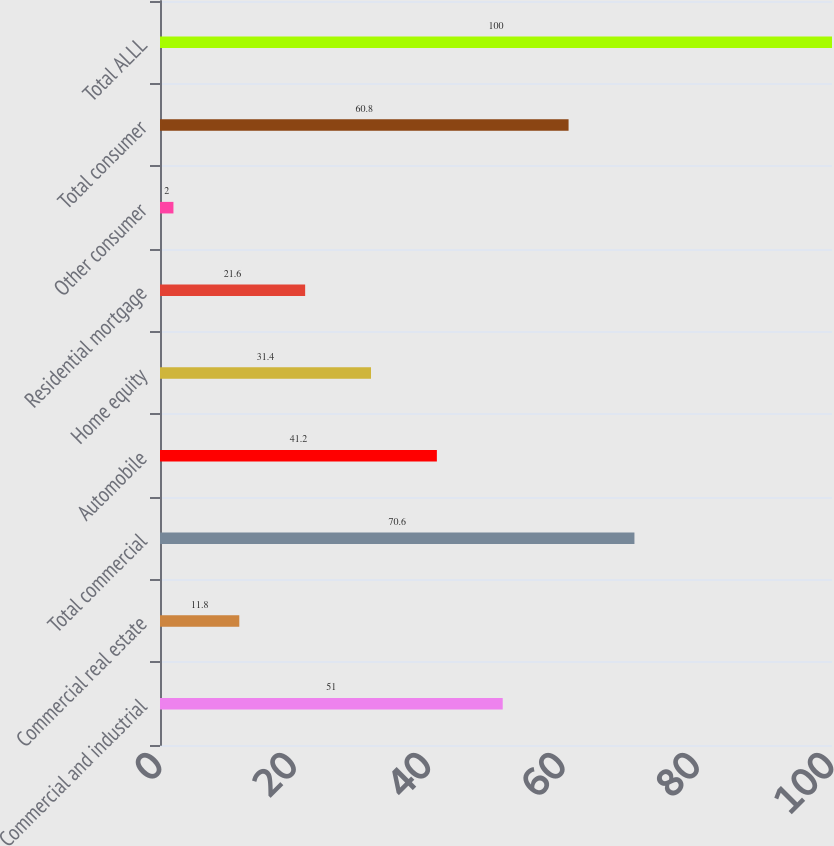Convert chart. <chart><loc_0><loc_0><loc_500><loc_500><bar_chart><fcel>Commercial and industrial<fcel>Commercial real estate<fcel>Total commercial<fcel>Automobile<fcel>Home equity<fcel>Residential mortgage<fcel>Other consumer<fcel>Total consumer<fcel>Total ALLL<nl><fcel>51<fcel>11.8<fcel>70.6<fcel>41.2<fcel>31.4<fcel>21.6<fcel>2<fcel>60.8<fcel>100<nl></chart> 